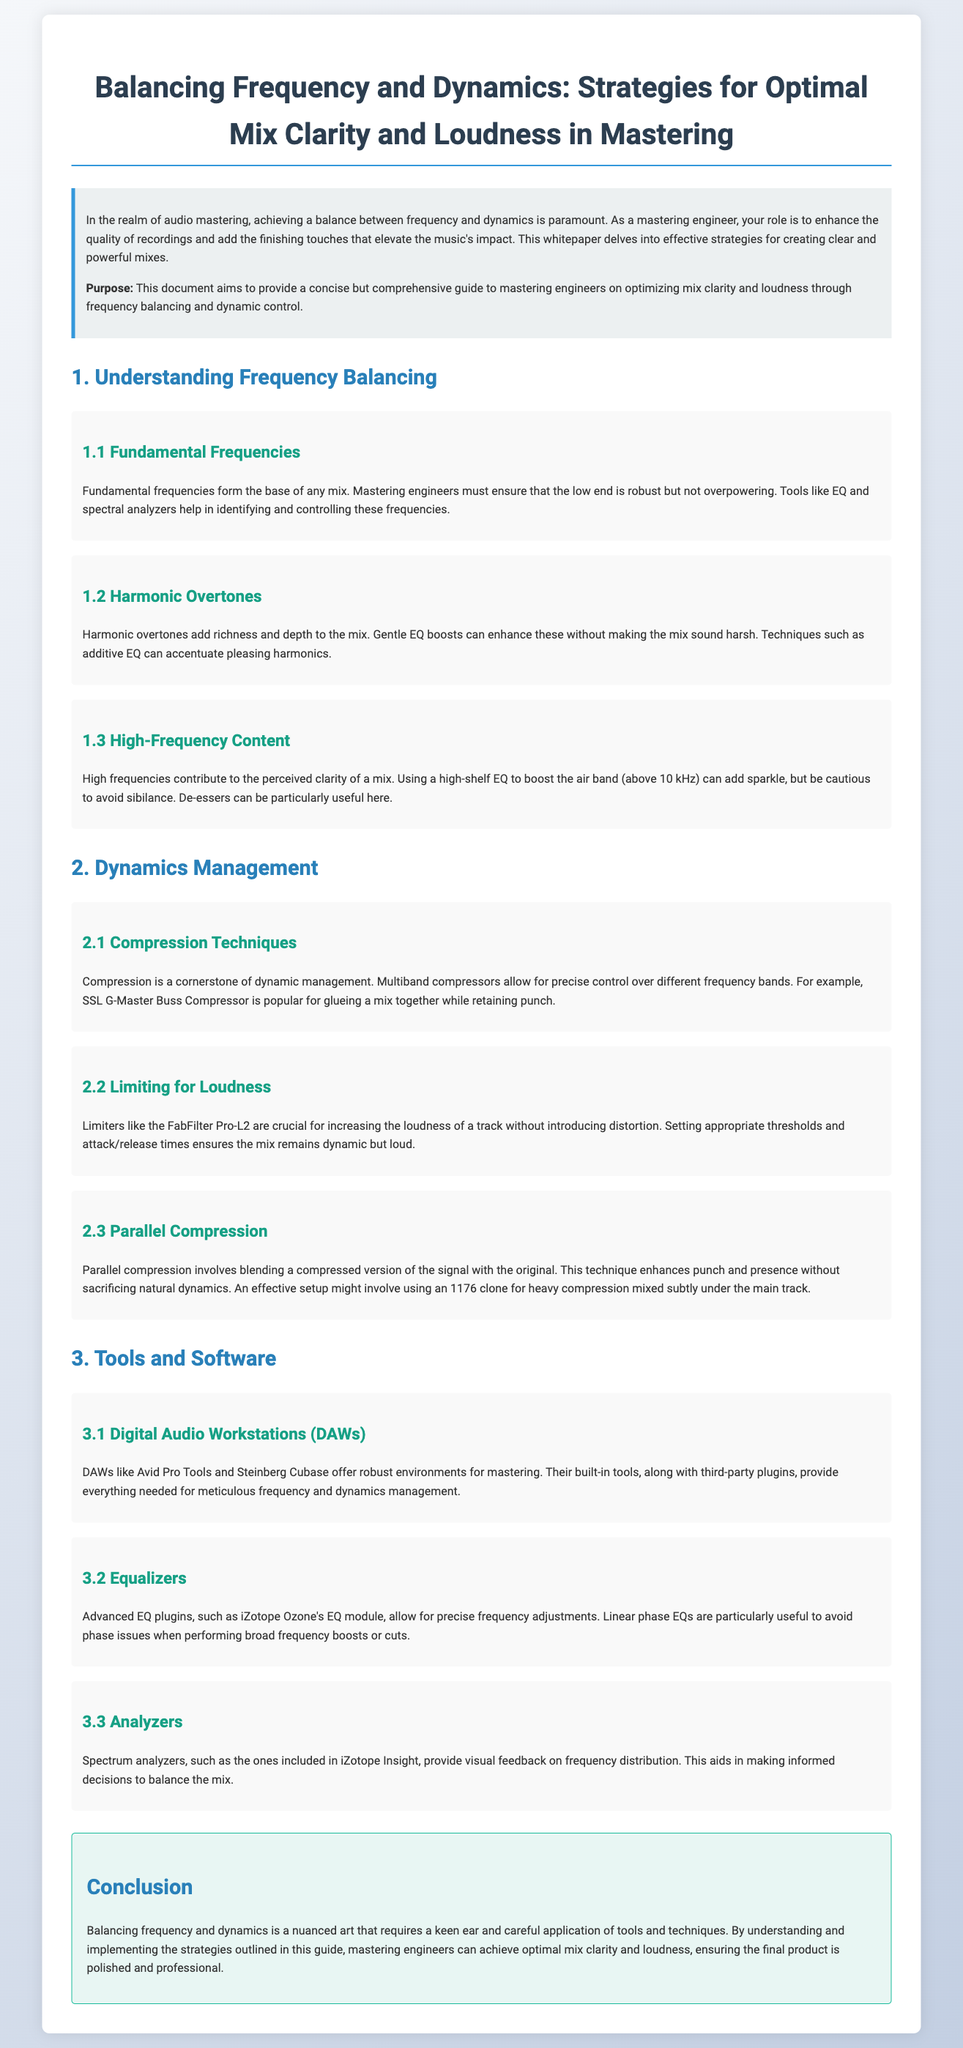What is the purpose of this document? The document aims to provide a concise but comprehensive guide to mastering engineers on optimizing mix clarity and loudness through frequency balancing and dynamic control.
Answer: optimizing mix clarity and loudness What tool is suggested for enhancing harmonic overtones? The document mentions techniques such as additive EQ to accentuate pleasing harmonics.
Answer: additive EQ What frequency range is referred to as the "air band"? The air band is described as being above 10 kHz in the document.
Answer: above 10 kHz Which compressor is noted for glueing a mix together? The SSL G-Master Buss Compressor is mentioned for this purpose.
Answer: SSL G-Master Buss Compressor What type of compression involves blending a compressed signal with the original? The technique described is called parallel compression.
Answer: parallel compression Which digital audio workstation is specifically mentioned in the document? Avid Pro Tools is highlighted among DAWs in the document.
Answer: Avid Pro Tools What is the main benefit of using a linear phase EQ? Linear phase EQs are particularly useful to avoid phase issues.
Answer: avoid phase issues What is the function of spectrum analyzers in mastering? Spectrum analyzers provide visual feedback on frequency distribution.
Answer: visual feedback on frequency distribution How does the document describe the overall goal of balancing frequency and dynamics? The document emphasizes achieving optimal mix clarity and loudness for a polished final product.
Answer: optimal mix clarity and loudness 